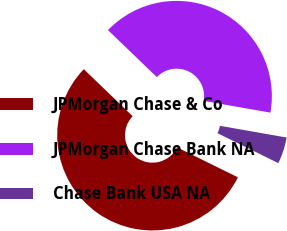<chart> <loc_0><loc_0><loc_500><loc_500><pie_chart><fcel>JPMorgan Chase & Co<fcel>JPMorgan Chase Bank NA<fcel>Chase Bank USA NA<nl><fcel>54.91%<fcel>40.58%<fcel>4.51%<nl></chart> 